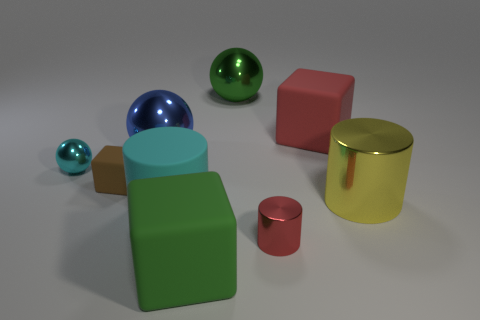How many shiny things are both to the right of the blue metal thing and in front of the large red matte cube?
Offer a terse response. 2. How many other objects are there of the same size as the red cylinder?
Give a very brief answer. 2. Is the number of objects that are in front of the small red metallic cylinder the same as the number of big cubes?
Your response must be concise. No. There is a sphere to the right of the big cyan rubber cylinder; does it have the same color as the block in front of the tiny metal cylinder?
Offer a very short reply. Yes. What is the block that is in front of the cyan metallic sphere and behind the green rubber object made of?
Your answer should be very brief. Rubber. What is the color of the large rubber cylinder?
Provide a succinct answer. Cyan. What number of other objects are the same shape as the cyan matte thing?
Provide a succinct answer. 2. Is the number of large blue metallic things in front of the yellow metallic object the same as the number of green balls on the left side of the blue thing?
Your answer should be very brief. Yes. What is the tiny brown object made of?
Offer a very short reply. Rubber. There is a big green object on the right side of the large green rubber object; what is it made of?
Provide a short and direct response. Metal. 